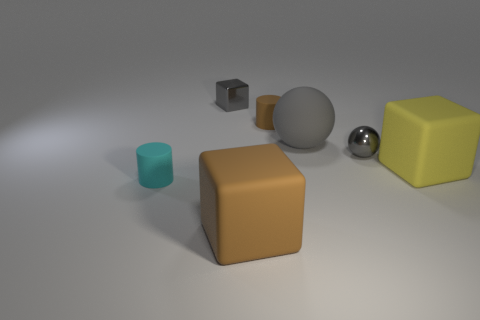Add 3 cylinders. How many objects exist? 10 Subtract all cubes. How many objects are left? 4 Subtract 1 yellow blocks. How many objects are left? 6 Subtract all large green metallic cubes. Subtract all brown matte cylinders. How many objects are left? 6 Add 7 big brown rubber blocks. How many big brown rubber blocks are left? 8 Add 4 small cylinders. How many small cylinders exist? 6 